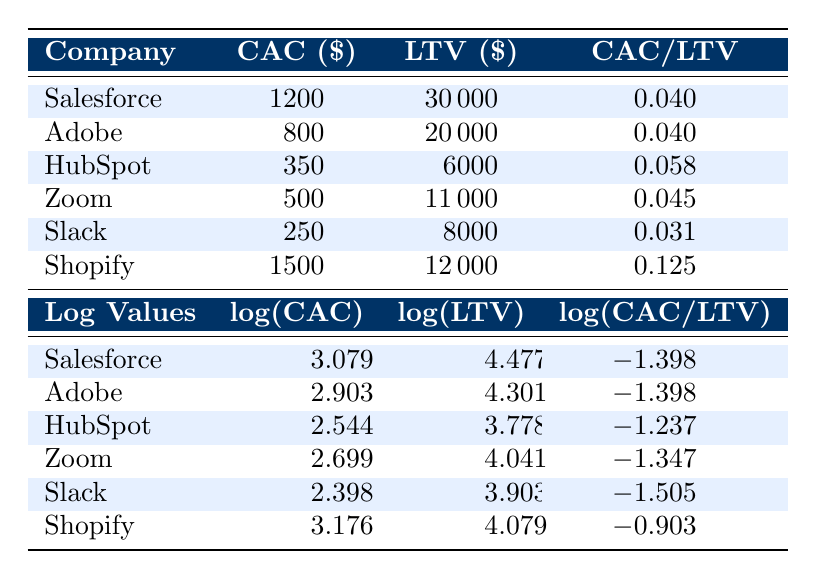What is the Customer Acquisition Cost of Salesforce? The table shows that Salesforce has a Customer Acquisition Cost of 1200.
Answer: 1200 Which company has the highest Lifetime Value? By comparing the LTV values in the table, Salesforce has the highest Lifetime Value of 30000.
Answer: Salesforce Is HubSpot's CAC/LTV ratio greater than 0.05? The table indicates that HubSpot has a CAC/LTV ratio of 0.058, which is indeed greater than 0.05.
Answer: Yes What is the average CAC for the companies listed? Adding the CAC values: 1200 + 800 + 350 + 500 + 250 + 1500 = 3600. There are 6 companies, so the average is 3600/6 = 600.
Answer: 600 How many companies have a CAC/LTV ratio below 0.05? Reviewing the table, we see that Slack has a ratio of 0.03125 and Zoom has a ratio of 0.045. That gives us 2 companies with a ratio below 0.05.
Answer: 2 Which company has the lowest Customer Acquisition Cost? The table lists Slack with the lowest Customer Acquisition Cost of 250.
Answer: Slack What is the difference between the LTV of Shopify and HubSpot? The LTV of Shopify is 12000, and that of HubSpot is 6000. The difference is 12000 - 6000 = 6000.
Answer: 6000 Is there any company with a negative log(CAC/LTV)? The log(CAC/LTV) values for all companies are negative, confirming that all CAC/LTV ratios are less than 1, showing no company has a positive log of that ratio.
Answer: Yes What is the log(LTV) of Adobe? From the table, the log(LTV) value for Adobe is 4.301.
Answer: 4.301 How do the log(CAC) values compare between Salesforce and Shopify? The log(CAC) value for Salesforce is 3.079 while for Shopify it is 3.176. Salesforce has a lower log(CAC) value than Shopify.
Answer: Salesforce has a lower log(CAC) value 